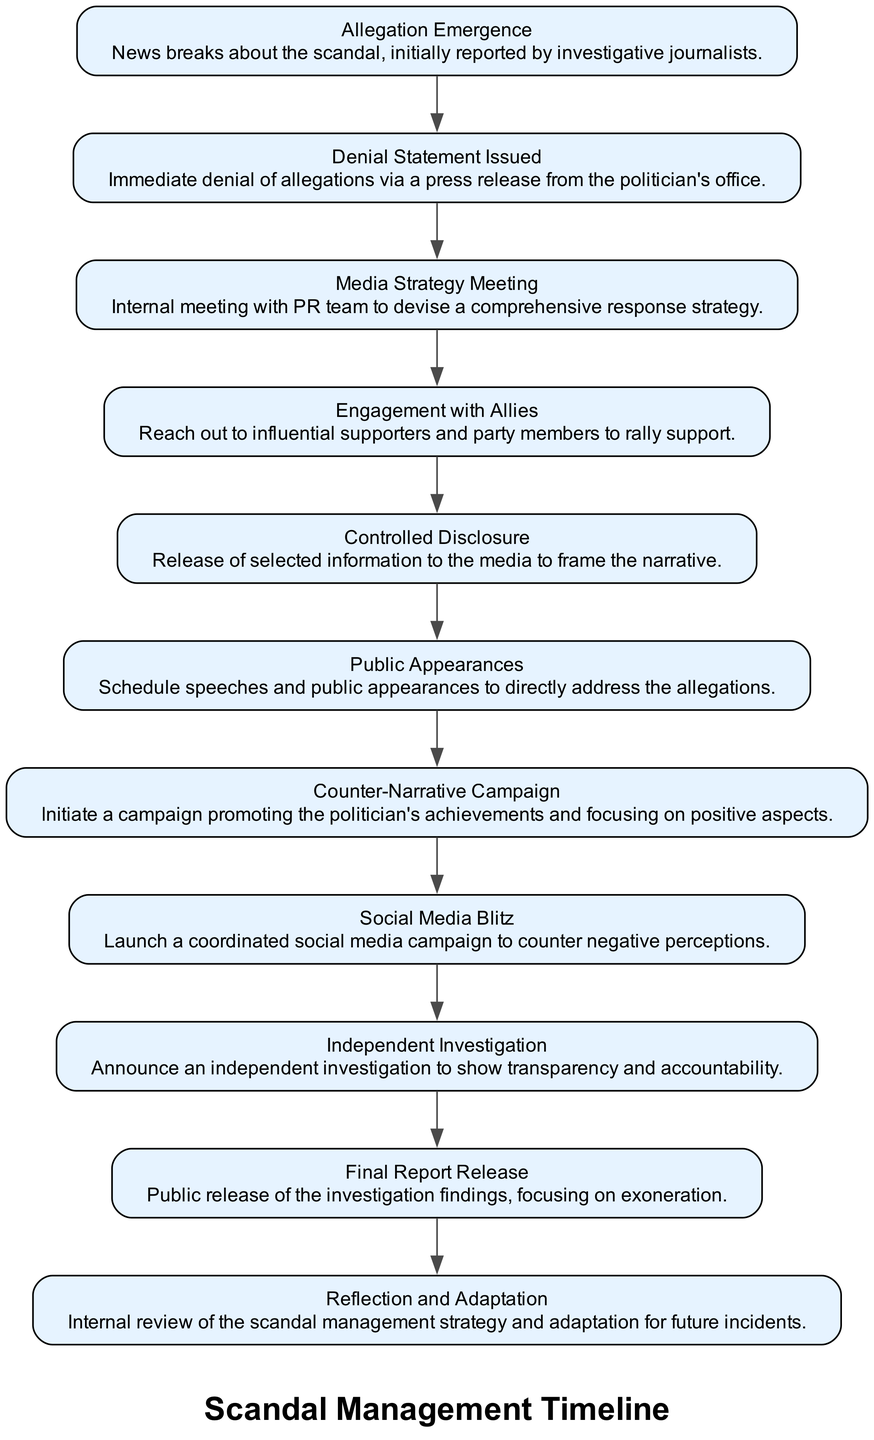What is the first event in the timeline? The first event in the timeline is "Allegation Emergence," which is the initial point where the scandal news is reported.
Answer: Allegation Emergence How many total events are depicted in the timeline? There are 11 events represented in the diagram, starting from the Allegation Emergence to Reflection and Adaptation.
Answer: 11 What event is directly following the "Media Strategy Meeting"? The event that directly follows the "Media Strategy Meeting" is "Engagement with Allies." This indicates a progression in the strategy after meeting with the PR team.
Answer: Engagement with Allies What is the last event listed in the timeline? The last event in the sequence is "Reflection and Adaptation," marking the end of the scandal management strategy.
Answer: Reflection and Adaptation Which event involves reaching out to supporters? The event that involves reaching out to supporters is "Engagement with Allies," where influential supporters and party members are contacted for support.
Answer: Engagement with Allies How many events involve public communication tactics? There are three events that involve public communication tactics: "Public Appearances," "Counter-Narrative Campaign," and "Social Media Blitz." These are aimed at addressing public perception following the allegations.
Answer: 3 What type of event is "Independent Investigation"? "Independent Investigation" is an event that emphasizes transparency and aims to build public trust through the announcement of an external inquiry.
Answer: Independent Investigation What are the two events that specifically focus on the media? The two events focusing on the media are "Controlled Disclosure," which involves selectively releasing information, and "Social Media Blitz," a coordinated effort to counter negative views online.
Answer: Controlled Disclosure and Social Media Blitz Which event reflects on the management strategy itself? The event that reflects on the management strategy is "Reflection and Adaptation," indicating an internal review process for improvement.
Answer: Reflection and Adaptation 